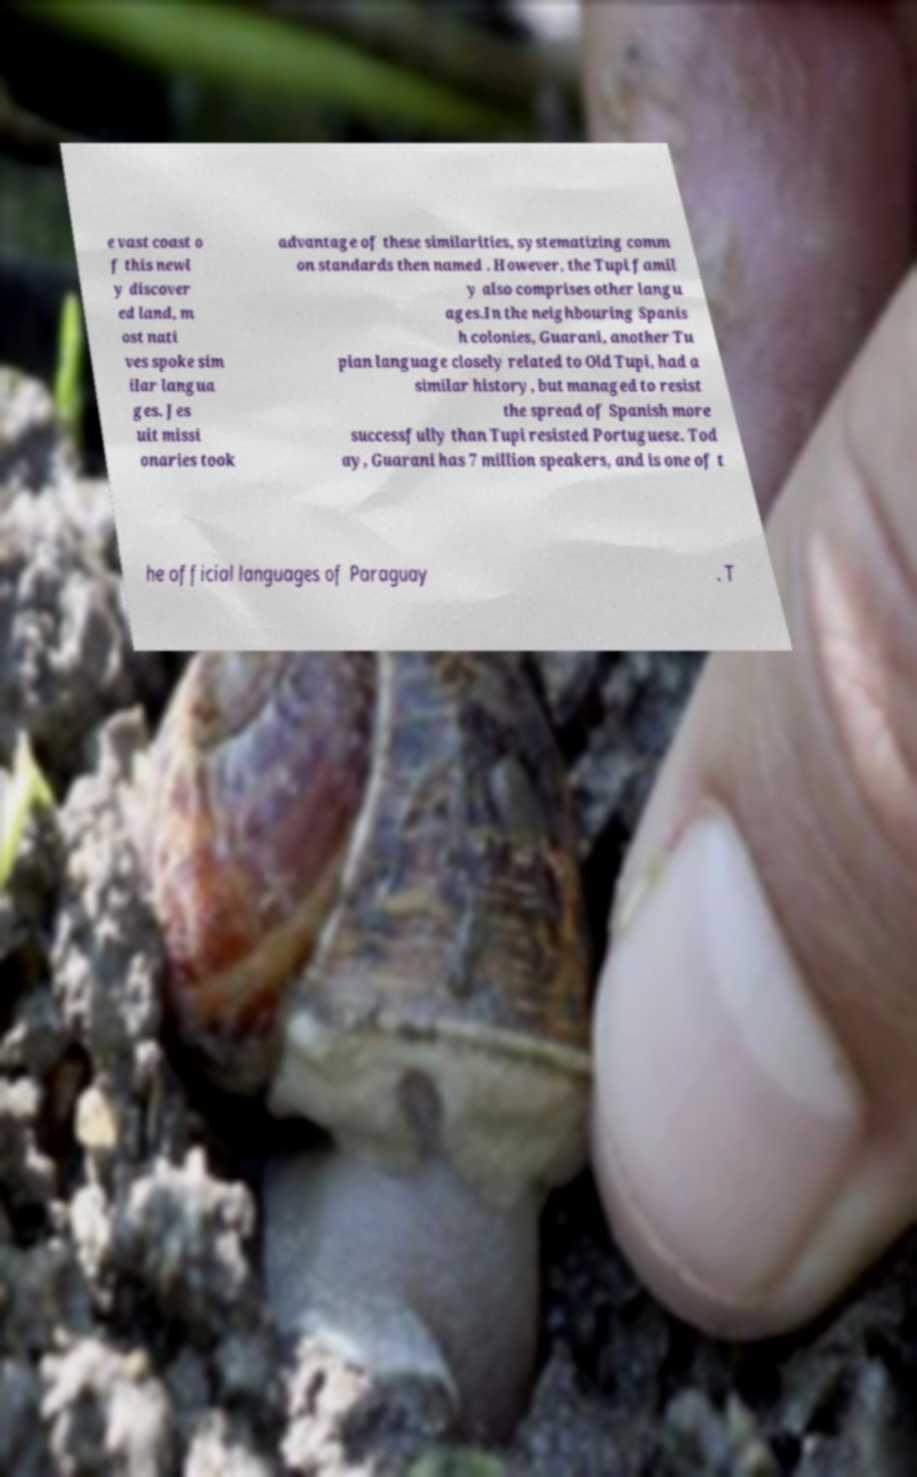Can you accurately transcribe the text from the provided image for me? e vast coast o f this newl y discover ed land, m ost nati ves spoke sim ilar langua ges. Jes uit missi onaries took advantage of these similarities, systematizing comm on standards then named . However, the Tupi famil y also comprises other langu ages.In the neighbouring Spanis h colonies, Guarani, another Tu pian language closely related to Old Tupi, had a similar history, but managed to resist the spread of Spanish more successfully than Tupi resisted Portuguese. Tod ay, Guarani has 7 million speakers, and is one of t he official languages of Paraguay . T 